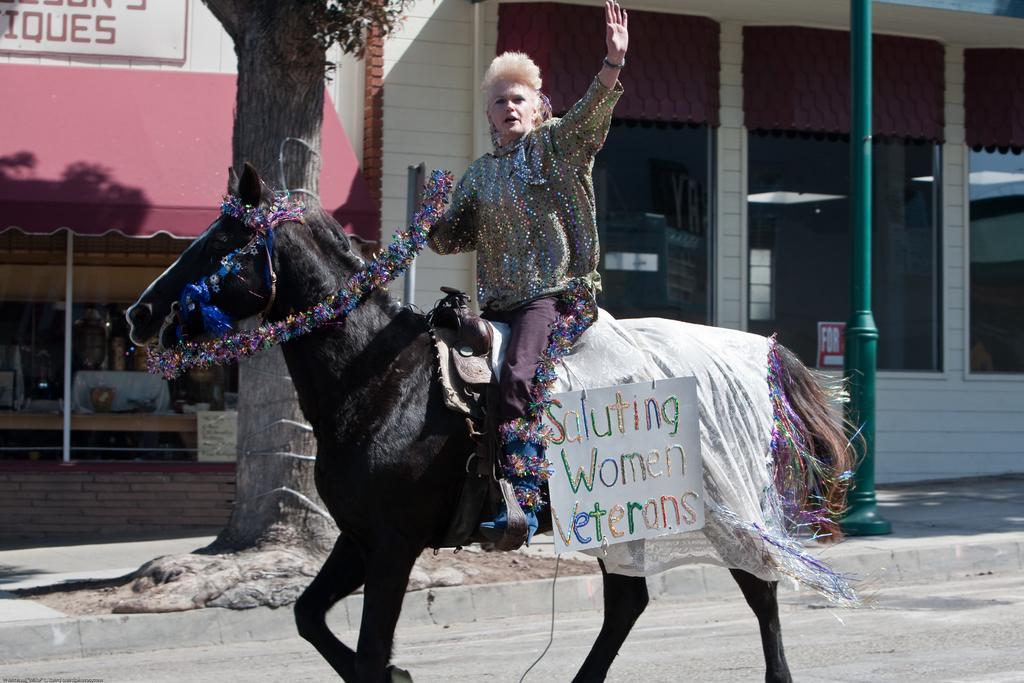Please provide a concise description of this image. In this picture there is a lady who is sitting on the horse at the center of the image and there is a tree at the left side of the image and there is a shop at the right side of the image. 